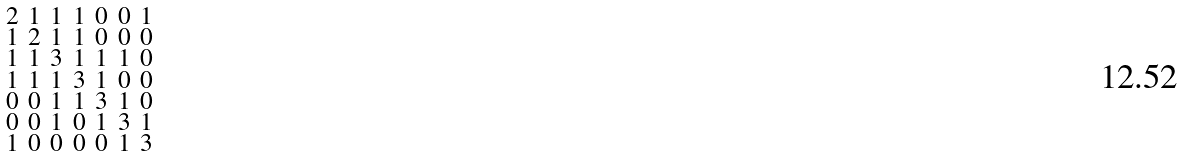<formula> <loc_0><loc_0><loc_500><loc_500>\begin{smallmatrix} 2 & 1 & 1 & 1 & 0 & 0 & 1 \\ 1 & 2 & 1 & 1 & 0 & 0 & 0 \\ 1 & 1 & 3 & 1 & 1 & 1 & 0 \\ 1 & 1 & 1 & 3 & 1 & 0 & 0 \\ 0 & 0 & 1 & 1 & 3 & 1 & 0 \\ 0 & 0 & 1 & 0 & 1 & 3 & 1 \\ 1 & 0 & 0 & 0 & 0 & 1 & 3 \end{smallmatrix}</formula> 